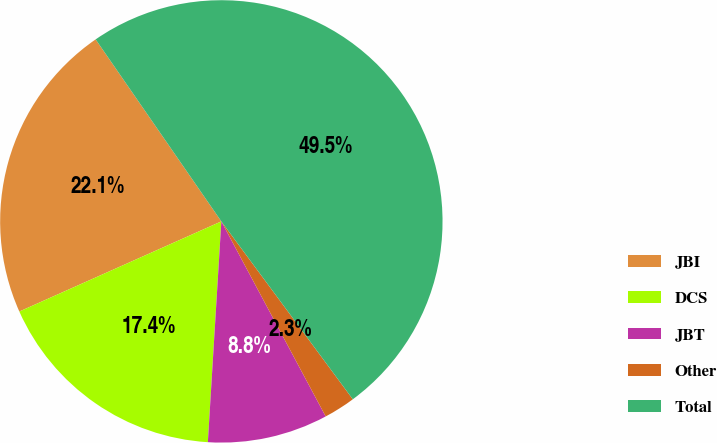Convert chart to OTSL. <chart><loc_0><loc_0><loc_500><loc_500><pie_chart><fcel>JBI<fcel>DCS<fcel>JBT<fcel>Other<fcel>Total<nl><fcel>22.06%<fcel>17.35%<fcel>8.79%<fcel>2.31%<fcel>49.49%<nl></chart> 